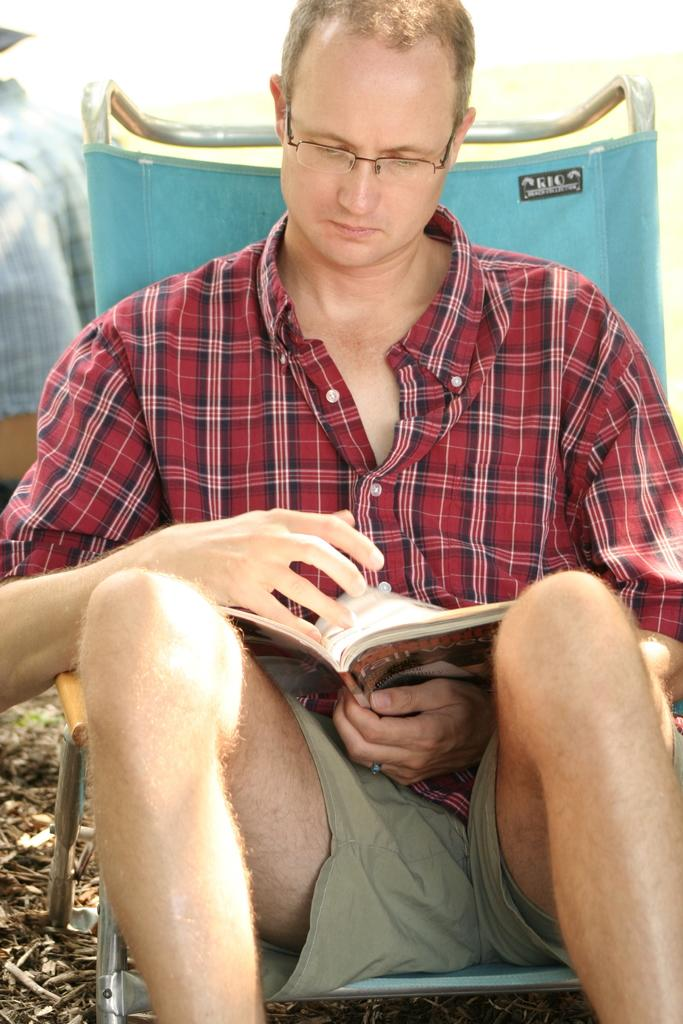What is the main subject in the foreground of the image? There is a person in the foreground of the image. What is the person doing in the image? The person is sitting on a chair and reading a book. What is the person holding in the image? The person is holding a book. What can be seen at the bottom of the image? There is some scrap at the bottom of the image. What type of tax is being discussed in the book the person is reading? There is no indication in the image that the book being read is about taxes, so it cannot be determined from the image. 